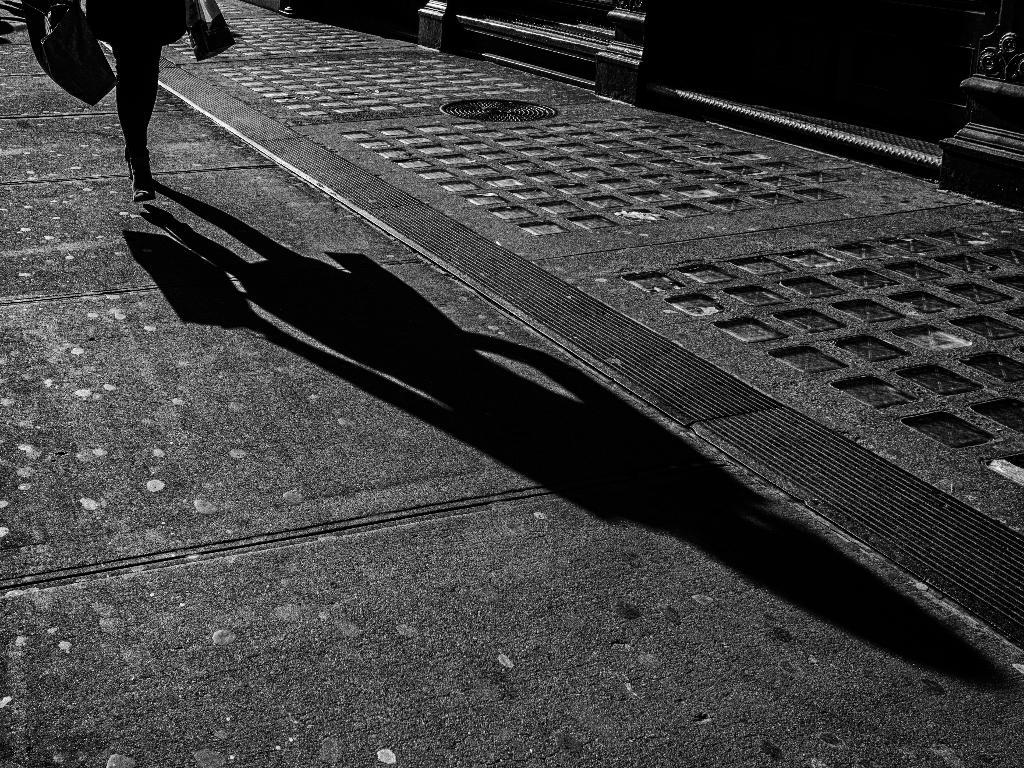What is happening in the image? There is a person in the image, and they are walking on the road. Can you describe the person's surroundings? The person's shadow is visible in the image. Is the person walking on a path made of bone in the image? No, the person is walking on a road, not a path made of bone. Is the person in danger of being crushed by something in the image? There is no indication of danger or anything that could crush the person in the image. 